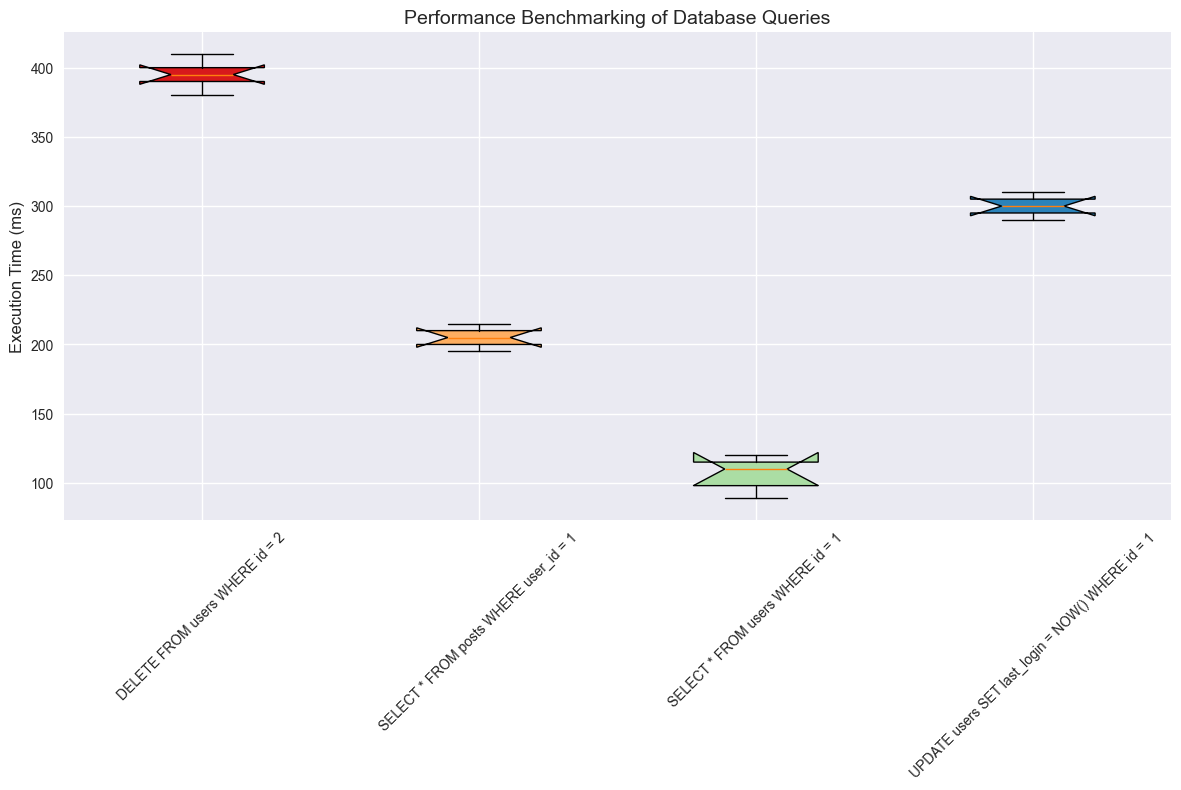What is the median execution time for the `DELETE FROM users WHERE id = 2` query? The median value for a dataset can be found at the middle position when the data is sorted. For `DELETE FROM users WHERE id = 2`, the sorted execution times are 380, 390, 395, 400, and 410, so the median is the middle value 395.
Answer: 395 Which query has the smallest range of execution times? The range of a dataset is the difference between the maximum and minimum values. By comparing the ranges: `SELECT * FROM users WHERE id = 1` (120-89=31), `SELECT * FROM posts WHERE user_id = 1` (215-195=20), `UPDATE users SET last_login = NOW() WHERE id = 1` (310-290=20), and `DELETE FROM users WHERE id = 2` (410-380=30), the queries `SELECT * FROM posts WHERE user_id = 1` and `UPDATE users SET last_login = NOW() WHERE id = 1` both have the smallest range of 20.
Answer: SELECT * FROM posts WHERE user_id = 1; UPDATE users SET last_login = NOW() WHERE id = 1 How do the median execution times of `SELECT * FROM users WHERE id = 1` and `SELECT * FROM posts WHERE user_id = 1` compare? The median is found by ordering the values and picking the middle one. For `SELECT * FROM users WHERE id = 1`, the median is 110 (sorted values: 89, 98, 110, 115, 120). For `SELECT * FROM posts WHERE user_id = 1`, the median is 205 (sorted values: 195, 200, 205, 210, 215). Comparing both, 110 is less than 205.
Answer: 110 < 205 What is the interquartile range (IQR) for `UPDATE users SET last_login = NOW() WHERE id = 1`? The IQR is calculated as Q3 minus Q1. For `UPDATE users SET last_login = NOW() WHERE id = 1`, the sorted values are 290, 295, 300, 305, 310. Q1 (25th percentile) is 295 and Q3 (75th percentile) is 305. Therefore, IQR = 305 - 295 = 10.
Answer: 10 Which query has the highest maximum execution time and what is it? By examining the highest value in each group: `SELECT * FROM users WHERE id = 1` (120), `SELECT * FROM posts WHERE user_id = 1` (215), `UPDATE users SET last_login = NOW() WHERE id = 1` (310), and `DELETE FROM users WHERE id = 2` (410), the `DELETE FROM users WHERE id = 2` query has the highest maximum execution time of 410 ms.
Answer: DELETE FROM users WHERE id = 2, 410 